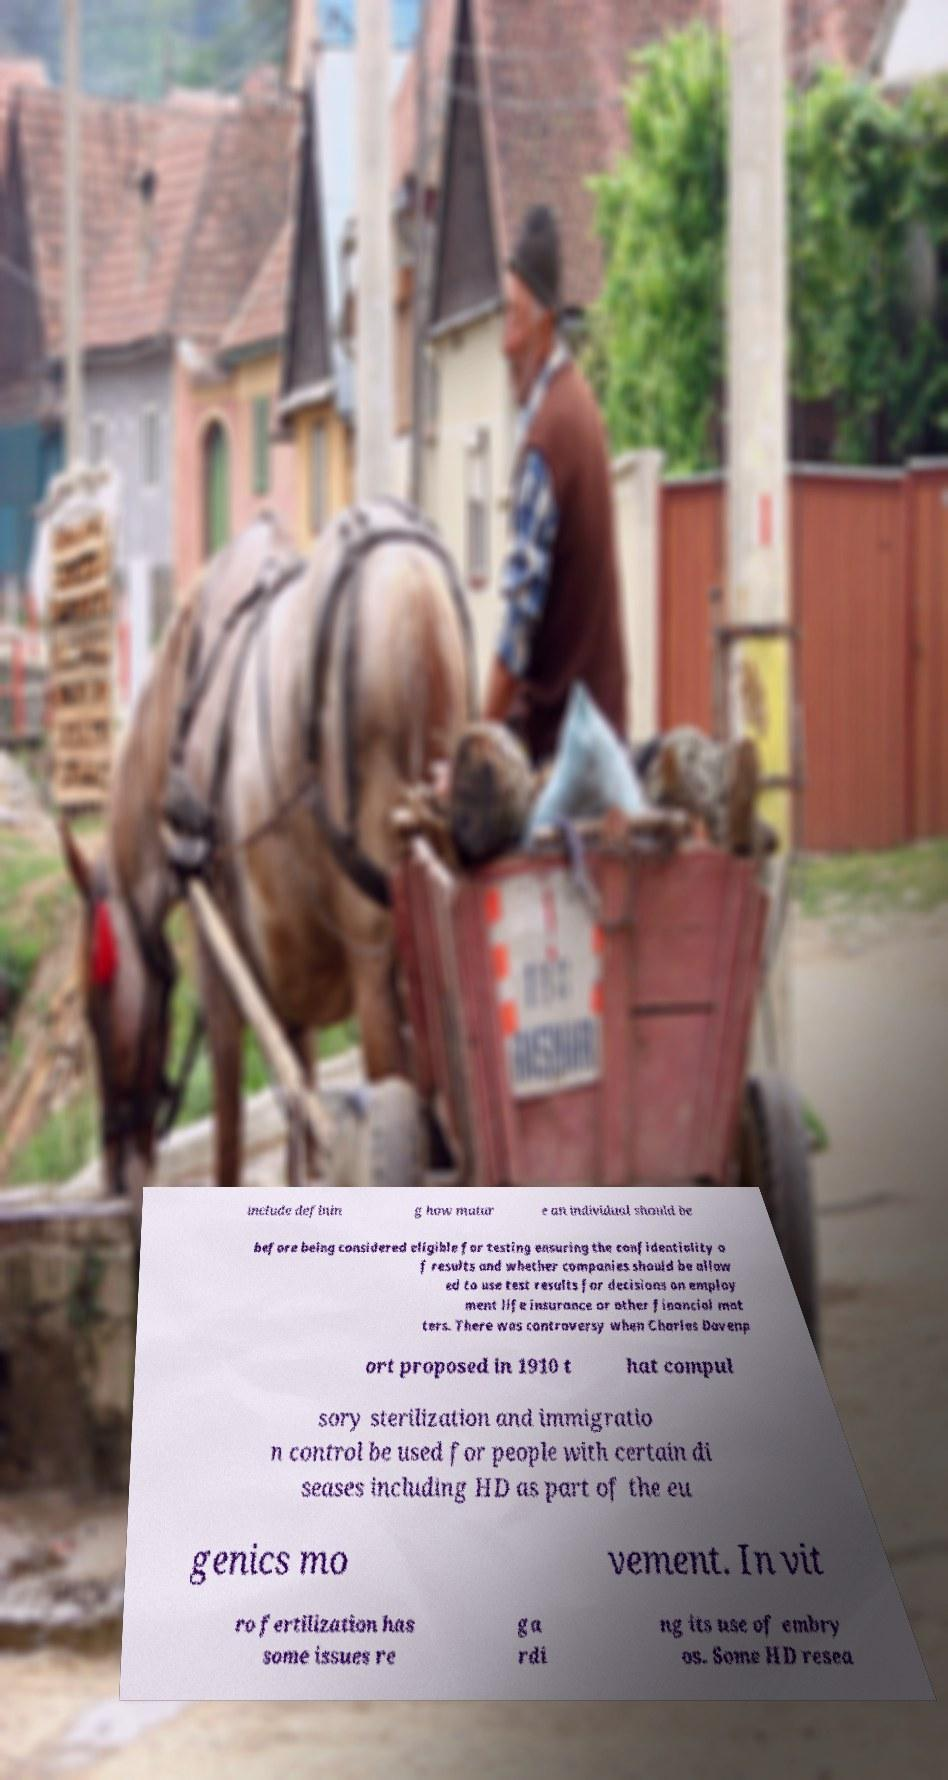Can you read and provide the text displayed in the image?This photo seems to have some interesting text. Can you extract and type it out for me? include definin g how matur e an individual should be before being considered eligible for testing ensuring the confidentiality o f results and whether companies should be allow ed to use test results for decisions on employ ment life insurance or other financial mat ters. There was controversy when Charles Davenp ort proposed in 1910 t hat compul sory sterilization and immigratio n control be used for people with certain di seases including HD as part of the eu genics mo vement. In vit ro fertilization has some issues re ga rdi ng its use of embry os. Some HD resea 